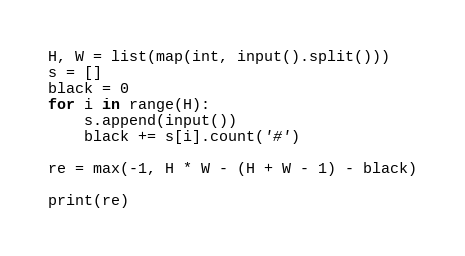<code> <loc_0><loc_0><loc_500><loc_500><_Python_>H, W = list(map(int, input().split()))
s = []
black = 0
for i in range(H):
    s.append(input())
    black += s[i].count('#')

re = max(-1, H * W - (H + W - 1) - black)

print(re)
</code> 